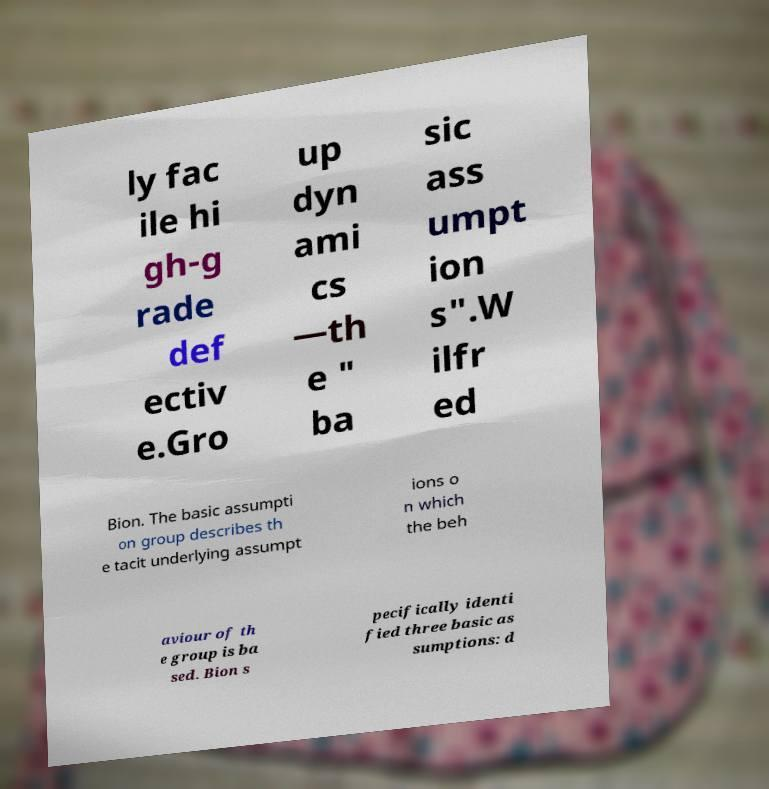What messages or text are displayed in this image? I need them in a readable, typed format. ly fac ile hi gh-g rade def ectiv e.Gro up dyn ami cs —th e " ba sic ass umpt ion s".W ilfr ed Bion. The basic assumpti on group describes th e tacit underlying assumpt ions o n which the beh aviour of th e group is ba sed. Bion s pecifically identi fied three basic as sumptions: d 